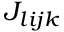<formula> <loc_0><loc_0><loc_500><loc_500>J _ { l i j k }</formula> 